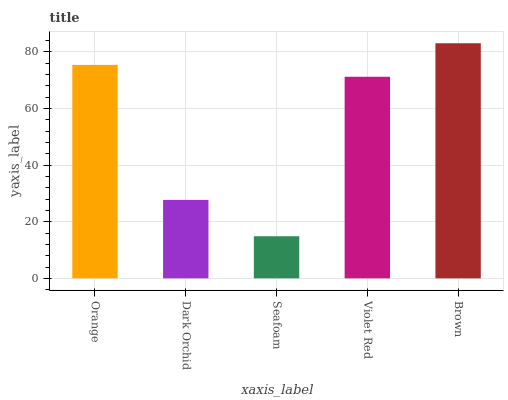Is Seafoam the minimum?
Answer yes or no. Yes. Is Brown the maximum?
Answer yes or no. Yes. Is Dark Orchid the minimum?
Answer yes or no. No. Is Dark Orchid the maximum?
Answer yes or no. No. Is Orange greater than Dark Orchid?
Answer yes or no. Yes. Is Dark Orchid less than Orange?
Answer yes or no. Yes. Is Dark Orchid greater than Orange?
Answer yes or no. No. Is Orange less than Dark Orchid?
Answer yes or no. No. Is Violet Red the high median?
Answer yes or no. Yes. Is Violet Red the low median?
Answer yes or no. Yes. Is Orange the high median?
Answer yes or no. No. Is Dark Orchid the low median?
Answer yes or no. No. 